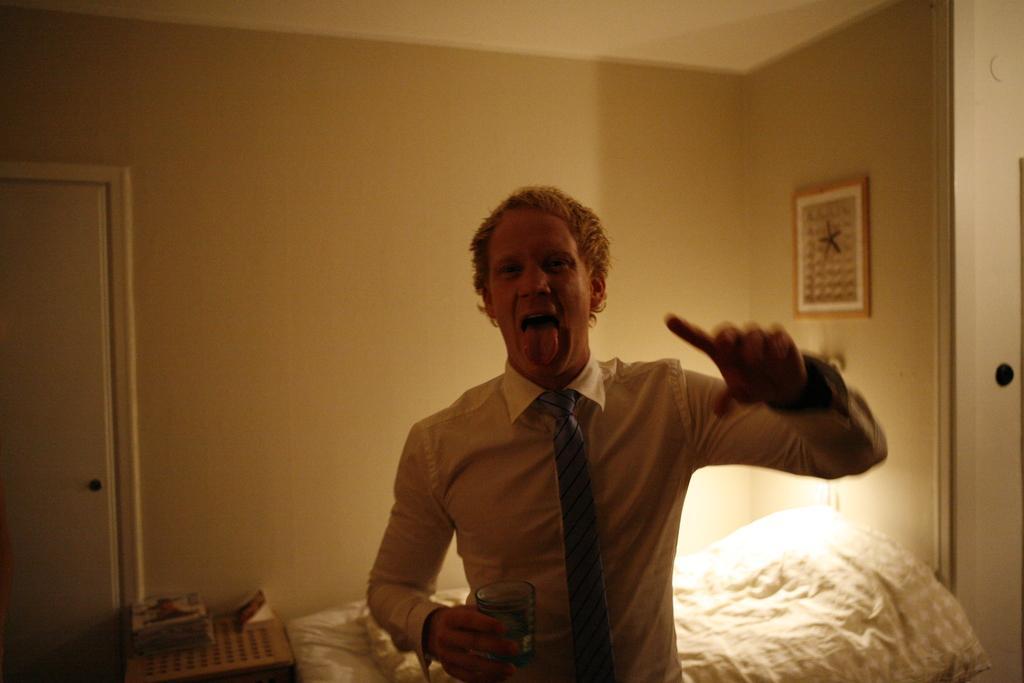Describe this image in one or two sentences. In this image there is a man in the middle who is holding the glass by keeping his tongue out. Behind him there is a bed. On the left side there is a door. In the background there is a wall on which there is a frame. Beside the bed there is a light. On the left side bottom there is a table on which there are books. 